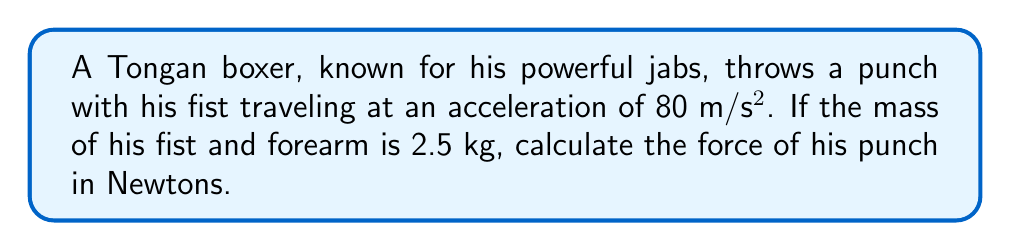Give your solution to this math problem. To solve this problem, we'll use Newton's Second Law of Motion, which states that the force (F) is equal to the mass (m) multiplied by the acceleration (a).

The formula is:

$$ F = m \times a $$

Given:
- Mass (m) = 2.5 kg
- Acceleration (a) = 80 m/s²

Let's substitute these values into the equation:

$$ F = 2.5 \text{ kg} \times 80 \text{ m/s}^2 $$

Now, we simply multiply these numbers:

$$ F = 200 \text{ N} $$

The unit of force is Newtons (N), which is equal to kg⋅m/s².
Answer: 200 N 